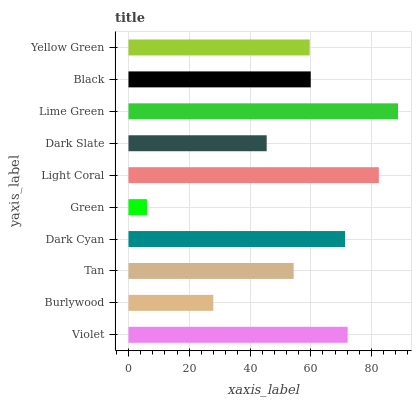Is Green the minimum?
Answer yes or no. Yes. Is Lime Green the maximum?
Answer yes or no. Yes. Is Burlywood the minimum?
Answer yes or no. No. Is Burlywood the maximum?
Answer yes or no. No. Is Violet greater than Burlywood?
Answer yes or no. Yes. Is Burlywood less than Violet?
Answer yes or no. Yes. Is Burlywood greater than Violet?
Answer yes or no. No. Is Violet less than Burlywood?
Answer yes or no. No. Is Black the high median?
Answer yes or no. Yes. Is Yellow Green the low median?
Answer yes or no. Yes. Is Dark Slate the high median?
Answer yes or no. No. Is Dark Cyan the low median?
Answer yes or no. No. 